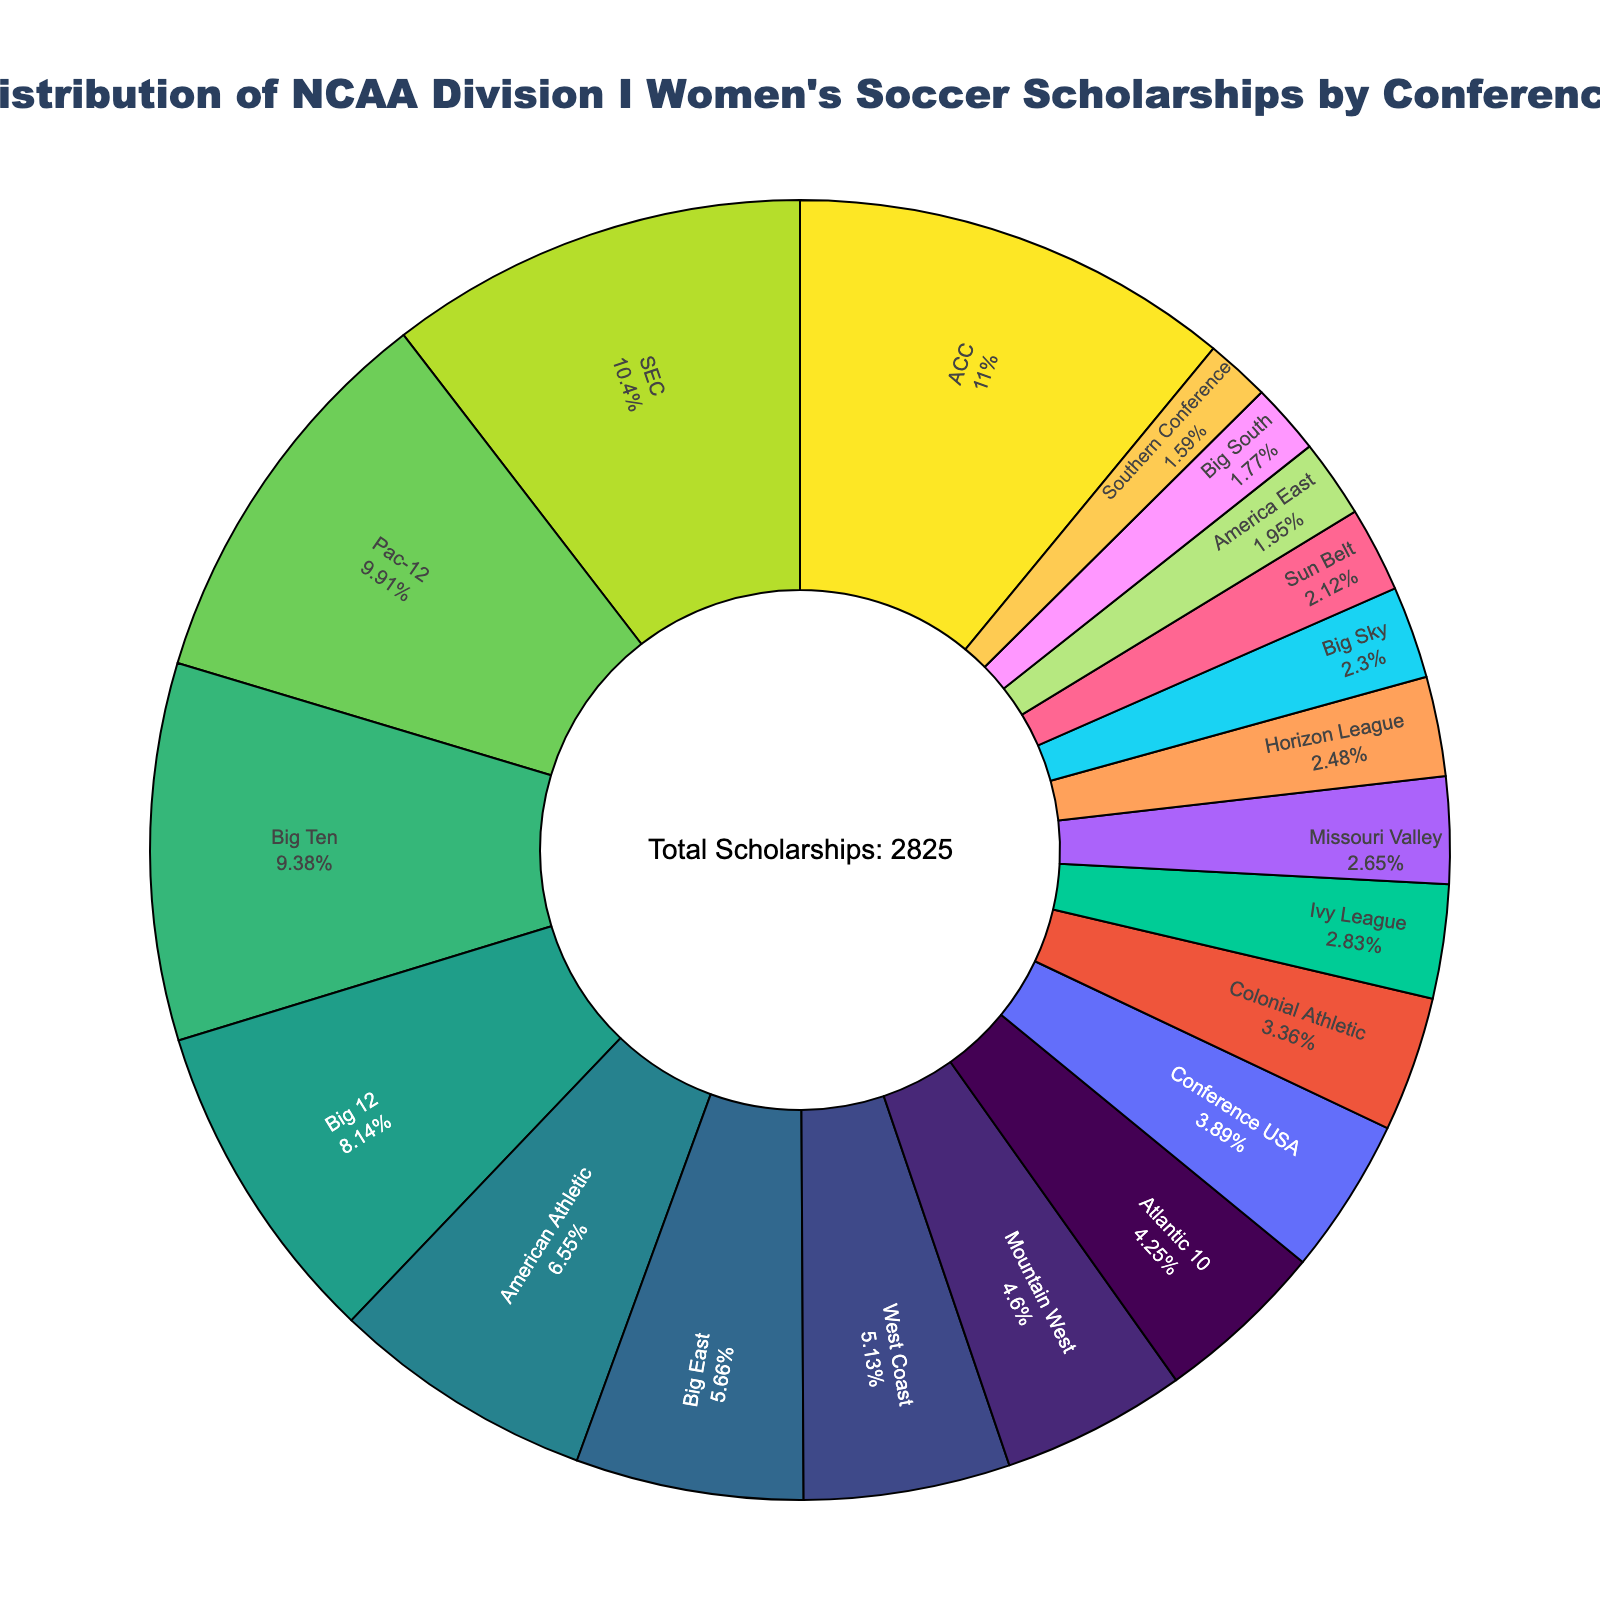What percentage of scholarships does the ACC conference hold? To find the percentage of scholarships held by the ACC conference, locate the ACC section of the pie chart and read the percentage displayed in that slice.
Answer: X% Which conference holds fewer scholarships, the Ivy League or the Mountain West? Compare the slices of the pie chart labeled "Ivy League" and "Mountain West" to determine which slice is smaller or has a lower percentage.
Answer: Ivy League What is the total number of scholarships across all conferences? Locate the annotation in the center of the pie chart that states the total number of scholarships.
Answer: 2850 How many more scholarships does the Pac-12 have compared to the Big 12? Identify the number of scholarships for the Pac-12 and the Big 12 from the pie chart, then subtract the number of scholarships of the Big 12 from the number of scholarships of the Pac-12.
Answer: 50 Which conference has the smallest slice in the pie chart? Identify the smallest slice in the pie chart by visually comparing the sizes of all the slices.
Answer: Southern Conference How much larger is the ACC's share of scholarships compared to the West Coast? Find the number of scholarships for the ACC and West Coast conferences from the pie chart, then subtract the West Coast number from the ACC number.
Answer: 165 What is the percentage difference between the SEC and the Big Ten conference scholarships? Find the percentages for SEC and Big Ten from the pie chart segments, then subtract the smaller percentage (Big Ten) from the larger percentage (SEC) to get the difference.
Answer: X% Rank the top three conferences in terms of scholarships offered. Examine the pie chart to identify which three slices are the largest and note their corresponding conferences in descending order.
Answer: ACC, SEC, Pac-12 Does the American Athletic conference hold more scholarships than the Colonial Athletic conference? Compare the respective slices of the American Athletic and Colonial Athletic conferences to see which is larger.
Answer: Yes If the scholarships from the Big Sky and Horizon League were combined, would their total be more than that of the Big East? Sum the scholarships from Big Sky and Horizon League and compare the total to the number of scholarships in the Big East slice.
Answer: No 